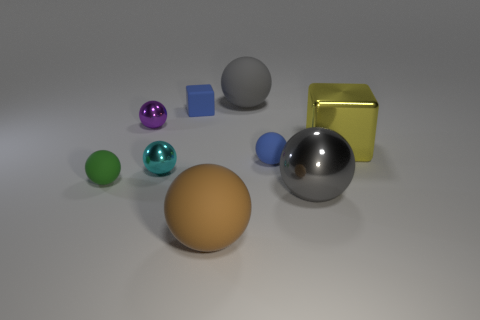There is a big object to the left of the large matte ball behind the large gray metallic thing; are there any big things behind it?
Provide a succinct answer. Yes. There is a big matte object that is to the right of the large brown ball; is its shape the same as the tiny blue matte thing to the right of the big brown matte ball?
Give a very brief answer. Yes. Are there more large gray matte spheres that are to the right of the brown matte sphere than red objects?
Your answer should be compact. Yes. What number of objects are gray things or small red rubber things?
Ensure brevity in your answer.  2. What is the color of the large metal block?
Provide a short and direct response. Yellow. What number of other objects are the same color as the rubber block?
Give a very brief answer. 1. Are there any small matte objects right of the small matte block?
Provide a short and direct response. Yes. What is the color of the tiny shiny sphere behind the cyan sphere that is to the left of the big gray thing behind the yellow object?
Ensure brevity in your answer.  Purple. What number of things are both to the left of the large brown rubber ball and behind the small cyan shiny object?
Your response must be concise. 2. How many cubes are either tiny rubber things or gray matte objects?
Your response must be concise. 1. 